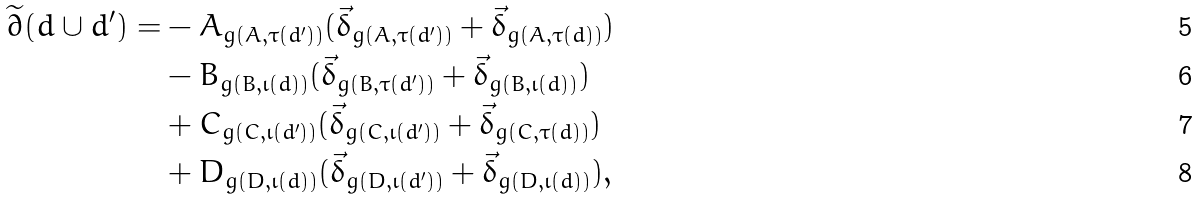<formula> <loc_0><loc_0><loc_500><loc_500>\widetilde { \partial } ( d \cup d ^ { \prime } ) = & - A _ { g ( A , \tau ( d ^ { \prime } ) ) } ( \vec { \delta } _ { g ( A , \tau ( d ^ { \prime } ) ) } + \vec { \delta } _ { g ( A , \tau ( d ) ) } ) \\ & - B _ { g ( B , \iota ( d ) ) } ( \vec { \delta } _ { g ( B , \tau ( d ^ { \prime } ) ) } + \vec { \delta } _ { g ( B , \iota ( d ) ) } ) \\ & + C _ { g ( C , \iota ( d ^ { \prime } ) ) } ( \vec { \delta } _ { g ( C , \iota ( d ^ { \prime } ) ) } + \vec { \delta } _ { g ( C , \tau ( d ) ) } ) \\ & + D _ { g ( D , \iota ( d ) ) } ( \vec { \delta } _ { g ( D , \iota ( d ^ { \prime } ) ) } + \vec { \delta } _ { g ( D , \iota ( d ) ) } ) ,</formula> 